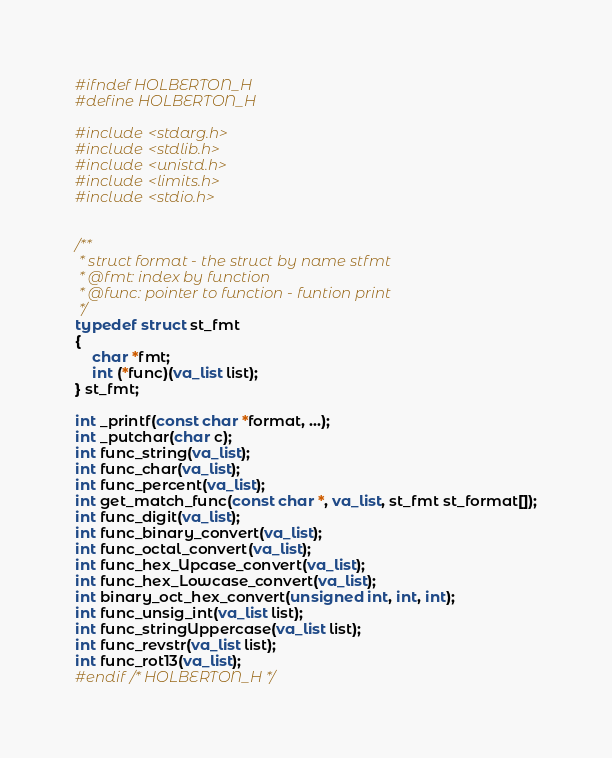Convert code to text. <code><loc_0><loc_0><loc_500><loc_500><_C_>#ifndef HOLBERTON_H
#define HOLBERTON_H

#include <stdarg.h>
#include <stdlib.h>
#include <unistd.h>
#include <limits.h>
#include <stdio.h>


/**
 * struct format - the struct by name stfmt
 * @fmt: index by function
 * @func: pointer to function - funtion print
 */
typedef struct st_fmt
{
	char *fmt;
	int (*func)(va_list list);
} st_fmt;

int _printf(const char *format, ...);
int _putchar(char c);
int func_string(va_list);
int func_char(va_list);
int func_percent(va_list);
int get_match_func(const char *, va_list, st_fmt st_format[]);
int func_digit(va_list);
int func_binary_convert(va_list);
int func_octal_convert(va_list);
int func_hex_Upcase_convert(va_list);
int func_hex_Lowcase_convert(va_list);
int binary_oct_hex_convert(unsigned int, int, int);
int func_unsig_int(va_list list);
int func_stringUppercase(va_list list);
int func_revstr(va_list list);
int func_rot13(va_list);
#endif /* HOLBERTON_H */
</code> 